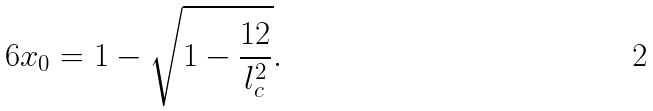<formula> <loc_0><loc_0><loc_500><loc_500>6 x _ { 0 } = 1 - \sqrt { 1 - \frac { 1 2 } { l _ { c } ^ { 2 } } } .</formula> 